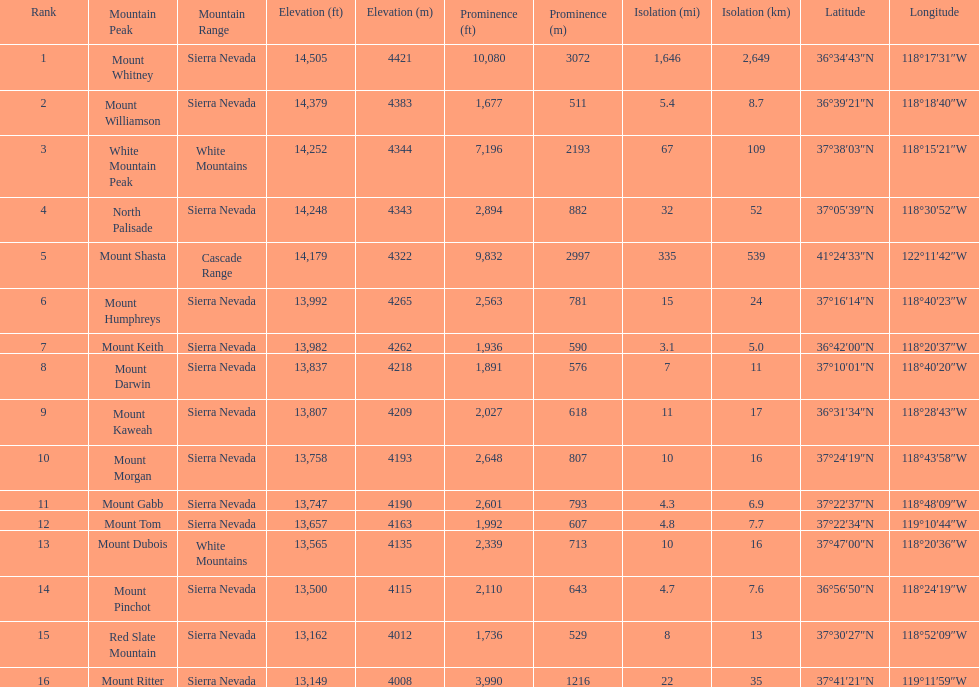Which mountain peak has the most isolation? Mount Whitney. Parse the table in full. {'header': ['Rank', 'Mountain Peak', 'Mountain Range', 'Elevation (ft)', 'Elevation (m)', 'Prominence (ft)', 'Prominence (m)', 'Isolation (mi)', 'Isolation (km)', 'Latitude', 'Longitude'], 'rows': [['1', 'Mount Whitney', 'Sierra Nevada', '14,505', '4421', '10,080', '3072', '1,646', '2,649', '36°34′43″N', '118°17′31″W'], ['2', 'Mount Williamson', 'Sierra Nevada', '14,379', '4383', '1,677', '511', '5.4', '8.7', '36°39′21″N', '118°18′40″W'], ['3', 'White Mountain Peak', 'White Mountains', '14,252', '4344', '7,196', '2193', '67', '109', '37°38′03″N', '118°15′21″W'], ['4', 'North Palisade', 'Sierra Nevada', '14,248', '4343', '2,894', '882', '32', '52', '37°05′39″N', '118°30′52″W'], ['5', 'Mount Shasta', 'Cascade Range', '14,179', '4322', '9,832', '2997', '335', '539', '41°24′33″N', '122°11′42″W'], ['6', 'Mount Humphreys', 'Sierra Nevada', '13,992', '4265', '2,563', '781', '15', '24', '37°16′14″N', '118°40′23″W'], ['7', 'Mount Keith', 'Sierra Nevada', '13,982', '4262', '1,936', '590', '3.1', '5.0', '36°42′00″N', '118°20′37″W'], ['8', 'Mount Darwin', 'Sierra Nevada', '13,837', '4218', '1,891', '576', '7', '11', '37°10′01″N', '118°40′20″W'], ['9', 'Mount Kaweah', 'Sierra Nevada', '13,807', '4209', '2,027', '618', '11', '17', '36°31′34″N', '118°28′43″W'], ['10', 'Mount Morgan', 'Sierra Nevada', '13,758', '4193', '2,648', '807', '10', '16', '37°24′19″N', '118°43′58″W'], ['11', 'Mount Gabb', 'Sierra Nevada', '13,747', '4190', '2,601', '793', '4.3', '6.9', '37°22′37″N', '118°48′09″W'], ['12', 'Mount Tom', 'Sierra Nevada', '13,657', '4163', '1,992', '607', '4.8', '7.7', '37°22′34″N', '119°10′44″W'], ['13', 'Mount Dubois', 'White Mountains', '13,565', '4135', '2,339', '713', '10', '16', '37°47′00″N', '118°20′36″W'], ['14', 'Mount Pinchot', 'Sierra Nevada', '13,500', '4115', '2,110', '643', '4.7', '7.6', '36°56′50″N', '118°24′19″W'], ['15', 'Red Slate Mountain', 'Sierra Nevada', '13,162', '4012', '1,736', '529', '8', '13', '37°30′27″N', '118°52′09″W'], ['16', 'Mount Ritter', 'Sierra Nevada', '13,149', '4008', '3,990', '1216', '22', '35', '37°41′21″N', '119°11′59″W']]} 